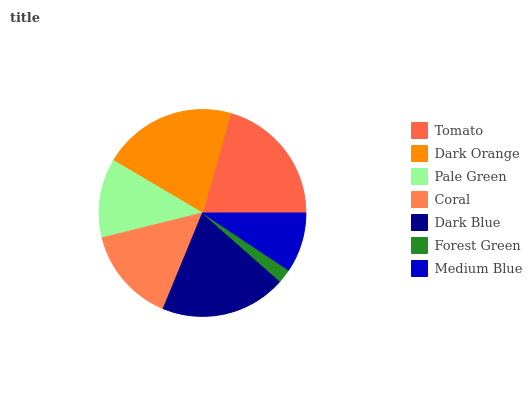Is Forest Green the minimum?
Answer yes or no. Yes. Is Dark Orange the maximum?
Answer yes or no. Yes. Is Pale Green the minimum?
Answer yes or no. No. Is Pale Green the maximum?
Answer yes or no. No. Is Dark Orange greater than Pale Green?
Answer yes or no. Yes. Is Pale Green less than Dark Orange?
Answer yes or no. Yes. Is Pale Green greater than Dark Orange?
Answer yes or no. No. Is Dark Orange less than Pale Green?
Answer yes or no. No. Is Coral the high median?
Answer yes or no. Yes. Is Coral the low median?
Answer yes or no. Yes. Is Pale Green the high median?
Answer yes or no. No. Is Pale Green the low median?
Answer yes or no. No. 